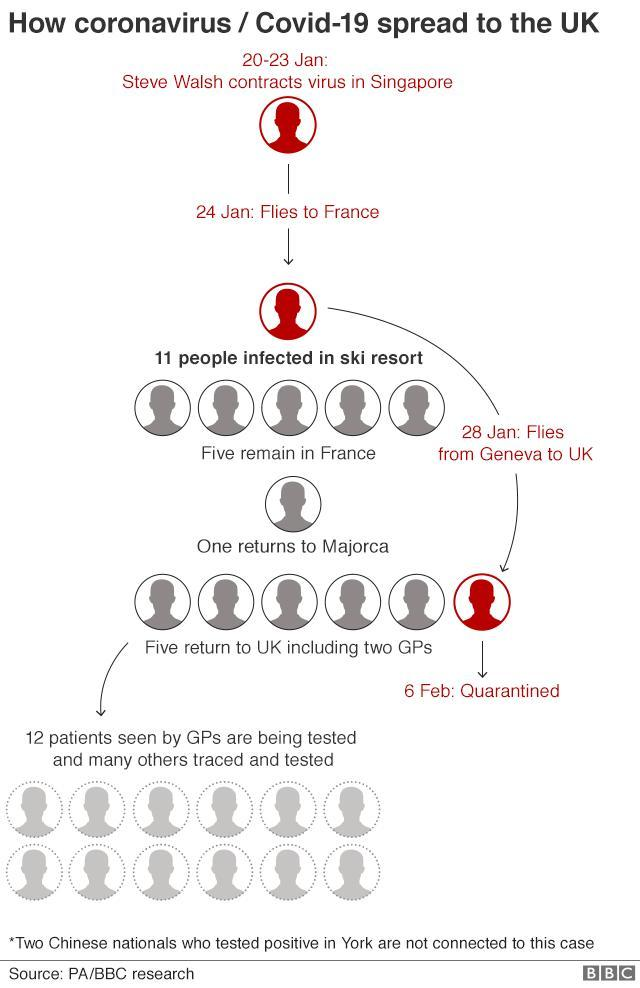How many people went quarantine on 6th Feb?
Answer the question with a short phrase. 1 